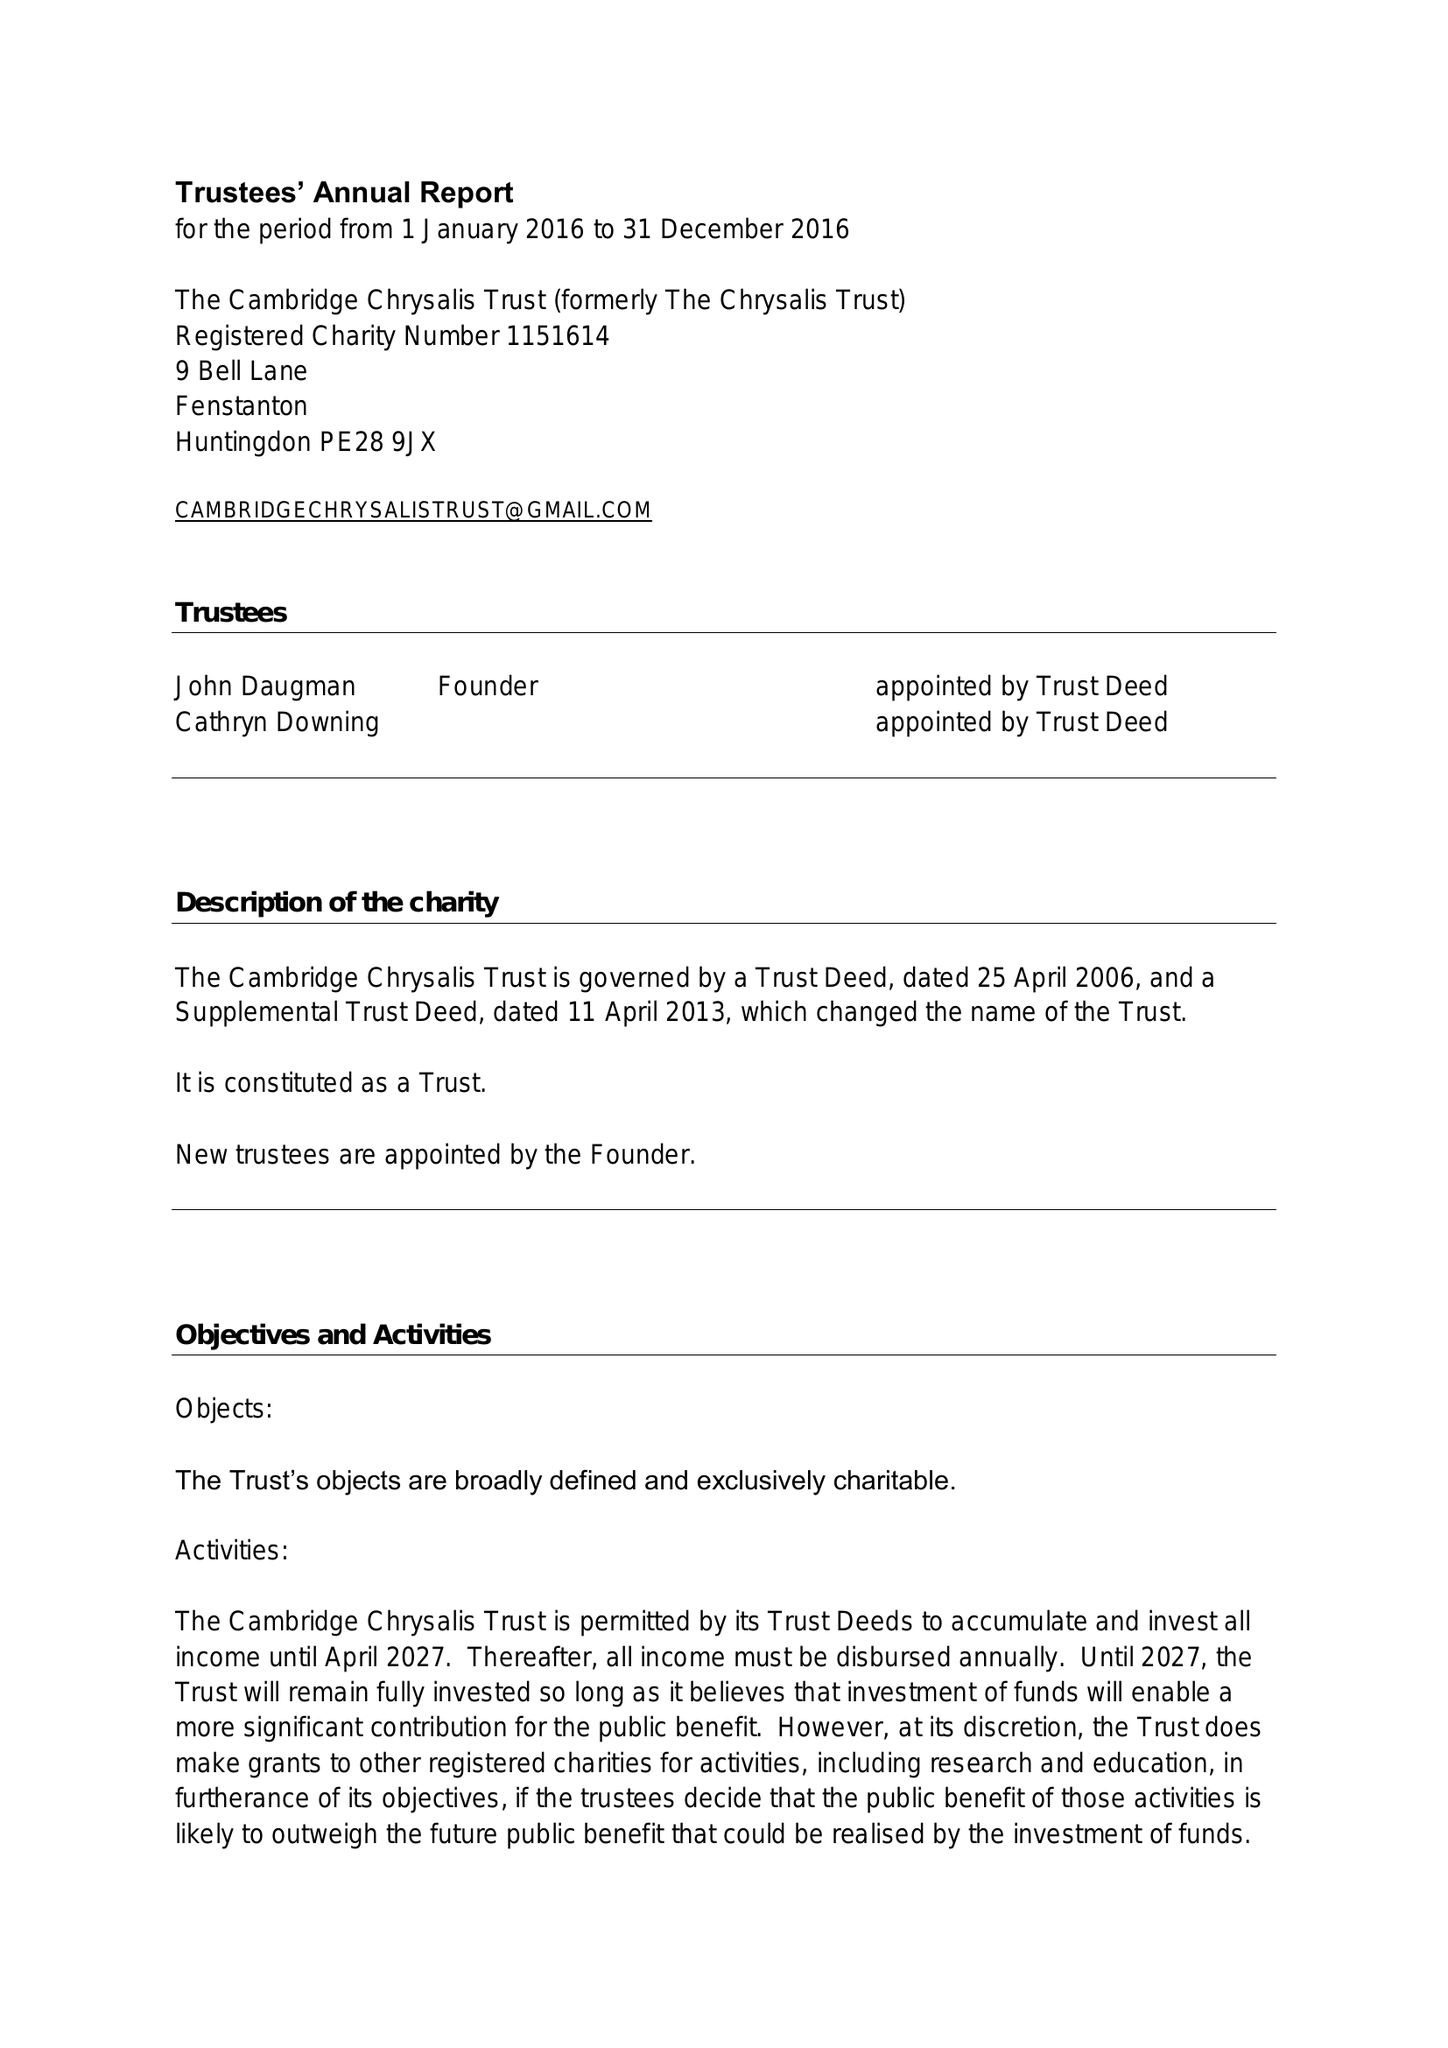What is the value for the income_annually_in_british_pounds?
Answer the question using a single word or phrase. 84465.00 